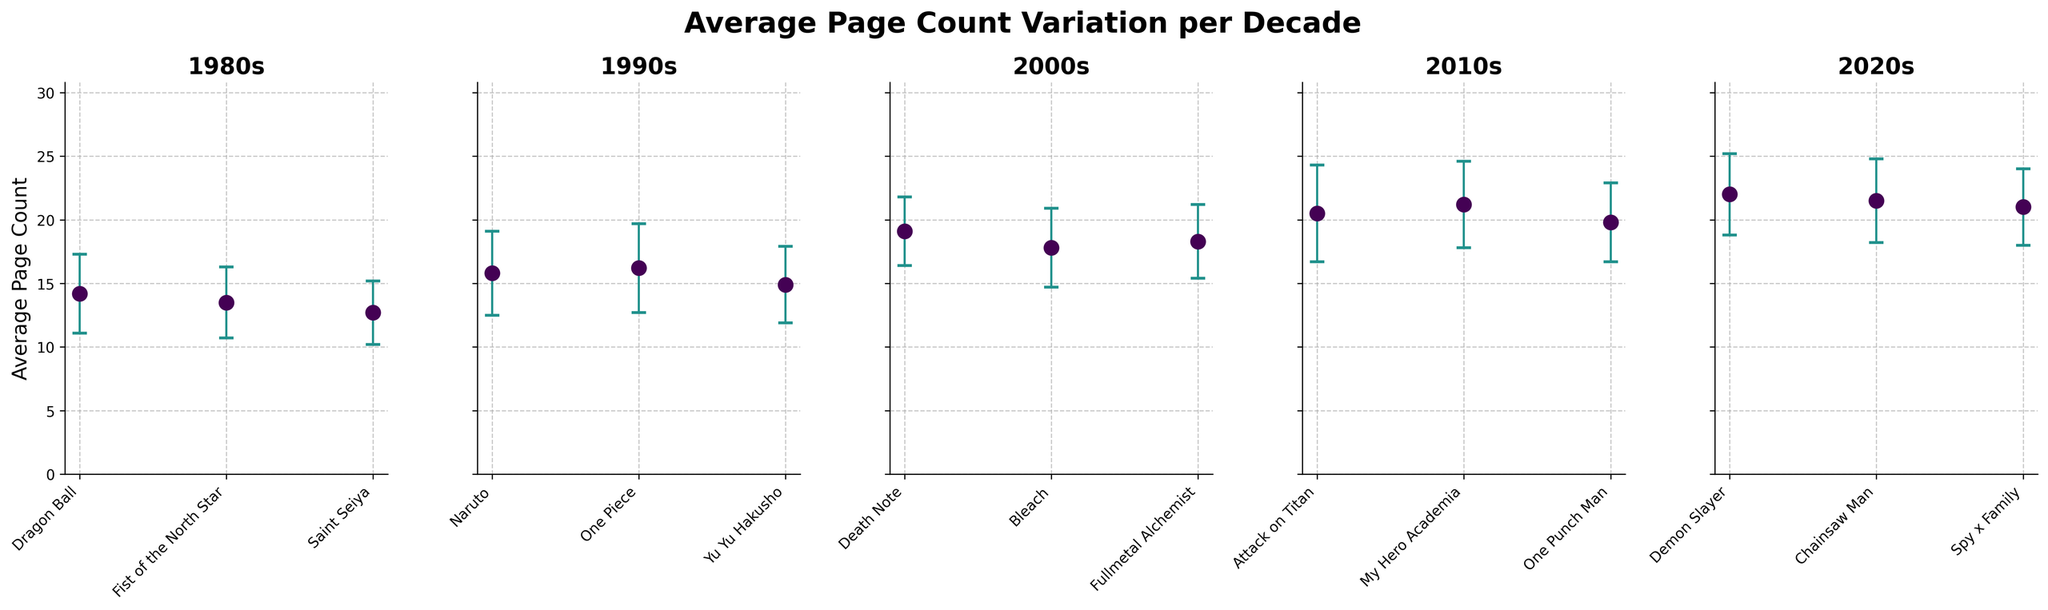Which manga series in the 1980s has the highest average page count? The subplot for the 1980s shows the average page counts for Dragon Ball, Fist of the North Star, and Saint Seiya. From these, Dragon Ball has the highest average page count of 14.2.
Answer: Dragon Ball How do the average page counts in the 2000s compare to those in the 1990s? From the subplots for the 1990s and 2000s, the 1990s have average page counts of 15.8 (Naruto), 16.2 (One Piece), and 14.9 (Yu Yu Hakusho). In the 2000s, the average page counts are 19.1 (Death Note), 17.8 (Bleach), and 18.3 (Fullmetal Alchemist). The values in the 2000s are generally higher than those in the 1990s.
Answer: Higher Which decade shows the highest variability in average page counts according to the error bars? The error bars indicate variability around the average page count. By comparing the subplots, the 2010s decade (Attack on Titan, My Hero Academia, One Punch Man) seems to have the highest range of variability as their error bars are the longest.
Answer: 2010s What is the range of average page counts for the series in the 2020s? To determine the range, we find the maximum and minimum values from the 2020s subplot. The series have average counts of 22.0 (Demon Slayer), 21.5 (Chainsaw Man), and 21.0 (Spy x Family). The range is 22.0 - 21.0.
Answer: 1.0 Between "One Piece" in the 1990s and "Bleach" in the 2000s, which series has a higher average page count and by how much? From the subplots, One Piece has an average page count of 16.2 while Bleach has 17.8. Calculating the difference, 17.8 - 16.2, Bleach has a higher average page count by 1.6.
Answer: Bleach, 1.6 Which series has the lowest average page count in the 1980s and by what value? The subplot for the 1980s shows the average page counts for Dragon Ball (14.2), Fist of the North Star (13.5), and Saint Seiya (12.7). Saint Seiya has the lowest average page count.
Answer: Saint Seiya, 12.7 Is the average page count consistently increasing across the decades? Examining the subplots from the 1980s to the 2020s, a general upward trend is visible. Average page counts rise from values around 12-14 in the 1980s, gradually increasing to the 20+ range by the 2020s. This indicates a consistent increase.
Answer: Yes How do the error bars for the manga series in the 2010s compare to those in the 2020s? The subplots for the 2010s and 2020s show the error bars for each series. On close inspection, the error bars in the 2010s (Attack on Titan, My Hero Academia, One Punch Man) appear slightly longer than those in the 2020s (Demon Slayer, Chainsaw Man, Spy x Family), indicating higher variability in the 2010s.
Answer: 2010s longer What is the average page count of Fullmetal Alchemist and how does it compare to Naruto? In the subplot for the 2000s, Fullmetal Alchemist has an average page count of 18.3. In the 1990s subplot, Naruto has an average of 15.8. Fullmetal Alchemist's average is higher by 18.3 - 15.8 = 2.5.
Answer: 18.3, higher by 2.5 